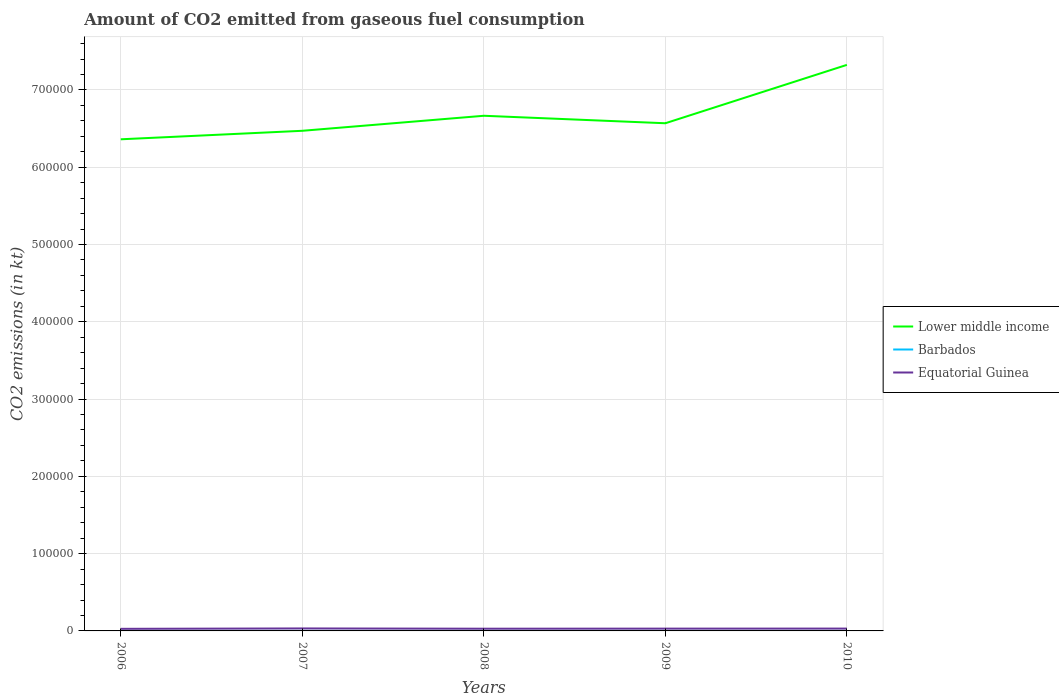How many different coloured lines are there?
Offer a very short reply. 3. Is the number of lines equal to the number of legend labels?
Offer a terse response. Yes. Across all years, what is the maximum amount of CO2 emitted in Equatorial Guinea?
Ensure brevity in your answer.  2709.91. In which year was the amount of CO2 emitted in Lower middle income maximum?
Give a very brief answer. 2006. What is the total amount of CO2 emitted in Lower middle income in the graph?
Offer a terse response. -8.53e+04. What is the difference between the highest and the second highest amount of CO2 emitted in Barbados?
Keep it short and to the point. 22. Is the amount of CO2 emitted in Lower middle income strictly greater than the amount of CO2 emitted in Equatorial Guinea over the years?
Your answer should be very brief. No. How many lines are there?
Offer a very short reply. 3. What is the difference between two consecutive major ticks on the Y-axis?
Keep it short and to the point. 1.00e+05. Are the values on the major ticks of Y-axis written in scientific E-notation?
Your answer should be very brief. No. Does the graph contain grids?
Keep it short and to the point. Yes. Where does the legend appear in the graph?
Give a very brief answer. Center right. How are the legend labels stacked?
Your answer should be compact. Vertical. What is the title of the graph?
Keep it short and to the point. Amount of CO2 emitted from gaseous fuel consumption. What is the label or title of the X-axis?
Provide a short and direct response. Years. What is the label or title of the Y-axis?
Provide a succinct answer. CO2 emissions (in kt). What is the CO2 emissions (in kt) in Lower middle income in 2006?
Offer a terse response. 6.36e+05. What is the CO2 emissions (in kt) in Barbados in 2006?
Your response must be concise. 51.34. What is the CO2 emissions (in kt) of Equatorial Guinea in 2006?
Keep it short and to the point. 2709.91. What is the CO2 emissions (in kt) of Lower middle income in 2007?
Ensure brevity in your answer.  6.47e+05. What is the CO2 emissions (in kt) in Barbados in 2007?
Offer a terse response. 44. What is the CO2 emissions (in kt) in Equatorial Guinea in 2007?
Give a very brief answer. 3212.29. What is the CO2 emissions (in kt) in Lower middle income in 2008?
Offer a terse response. 6.67e+05. What is the CO2 emissions (in kt) in Barbados in 2008?
Keep it short and to the point. 51.34. What is the CO2 emissions (in kt) of Equatorial Guinea in 2008?
Give a very brief answer. 2860.26. What is the CO2 emissions (in kt) in Lower middle income in 2009?
Make the answer very short. 6.57e+05. What is the CO2 emissions (in kt) of Barbados in 2009?
Provide a succinct answer. 33. What is the CO2 emissions (in kt) in Equatorial Guinea in 2009?
Offer a very short reply. 2973.94. What is the CO2 emissions (in kt) of Lower middle income in 2010?
Offer a terse response. 7.32e+05. What is the CO2 emissions (in kt) in Barbados in 2010?
Provide a succinct answer. 29.34. What is the CO2 emissions (in kt) of Equatorial Guinea in 2010?
Provide a succinct answer. 3032.61. Across all years, what is the maximum CO2 emissions (in kt) in Lower middle income?
Offer a terse response. 7.32e+05. Across all years, what is the maximum CO2 emissions (in kt) of Barbados?
Give a very brief answer. 51.34. Across all years, what is the maximum CO2 emissions (in kt) in Equatorial Guinea?
Offer a terse response. 3212.29. Across all years, what is the minimum CO2 emissions (in kt) in Lower middle income?
Ensure brevity in your answer.  6.36e+05. Across all years, what is the minimum CO2 emissions (in kt) of Barbados?
Provide a short and direct response. 29.34. Across all years, what is the minimum CO2 emissions (in kt) in Equatorial Guinea?
Your response must be concise. 2709.91. What is the total CO2 emissions (in kt) in Lower middle income in the graph?
Make the answer very short. 3.34e+06. What is the total CO2 emissions (in kt) of Barbados in the graph?
Make the answer very short. 209.02. What is the total CO2 emissions (in kt) in Equatorial Guinea in the graph?
Keep it short and to the point. 1.48e+04. What is the difference between the CO2 emissions (in kt) in Lower middle income in 2006 and that in 2007?
Provide a short and direct response. -1.10e+04. What is the difference between the CO2 emissions (in kt) in Barbados in 2006 and that in 2007?
Provide a succinct answer. 7.33. What is the difference between the CO2 emissions (in kt) of Equatorial Guinea in 2006 and that in 2007?
Ensure brevity in your answer.  -502.38. What is the difference between the CO2 emissions (in kt) of Lower middle income in 2006 and that in 2008?
Ensure brevity in your answer.  -3.04e+04. What is the difference between the CO2 emissions (in kt) in Barbados in 2006 and that in 2008?
Give a very brief answer. 0. What is the difference between the CO2 emissions (in kt) of Equatorial Guinea in 2006 and that in 2008?
Your response must be concise. -150.35. What is the difference between the CO2 emissions (in kt) of Lower middle income in 2006 and that in 2009?
Offer a terse response. -2.08e+04. What is the difference between the CO2 emissions (in kt) in Barbados in 2006 and that in 2009?
Give a very brief answer. 18.34. What is the difference between the CO2 emissions (in kt) of Equatorial Guinea in 2006 and that in 2009?
Your response must be concise. -264.02. What is the difference between the CO2 emissions (in kt) in Lower middle income in 2006 and that in 2010?
Your answer should be compact. -9.63e+04. What is the difference between the CO2 emissions (in kt) of Barbados in 2006 and that in 2010?
Provide a succinct answer. 22. What is the difference between the CO2 emissions (in kt) of Equatorial Guinea in 2006 and that in 2010?
Your answer should be compact. -322.7. What is the difference between the CO2 emissions (in kt) of Lower middle income in 2007 and that in 2008?
Your answer should be very brief. -1.94e+04. What is the difference between the CO2 emissions (in kt) of Barbados in 2007 and that in 2008?
Offer a very short reply. -7.33. What is the difference between the CO2 emissions (in kt) in Equatorial Guinea in 2007 and that in 2008?
Your answer should be compact. 352.03. What is the difference between the CO2 emissions (in kt) in Lower middle income in 2007 and that in 2009?
Give a very brief answer. -9769.55. What is the difference between the CO2 emissions (in kt) in Barbados in 2007 and that in 2009?
Your response must be concise. 11. What is the difference between the CO2 emissions (in kt) in Equatorial Guinea in 2007 and that in 2009?
Your answer should be compact. 238.35. What is the difference between the CO2 emissions (in kt) in Lower middle income in 2007 and that in 2010?
Offer a terse response. -8.53e+04. What is the difference between the CO2 emissions (in kt) of Barbados in 2007 and that in 2010?
Your response must be concise. 14.67. What is the difference between the CO2 emissions (in kt) in Equatorial Guinea in 2007 and that in 2010?
Your answer should be compact. 179.68. What is the difference between the CO2 emissions (in kt) of Lower middle income in 2008 and that in 2009?
Provide a short and direct response. 9672.51. What is the difference between the CO2 emissions (in kt) of Barbados in 2008 and that in 2009?
Offer a terse response. 18.34. What is the difference between the CO2 emissions (in kt) of Equatorial Guinea in 2008 and that in 2009?
Your answer should be compact. -113.68. What is the difference between the CO2 emissions (in kt) in Lower middle income in 2008 and that in 2010?
Make the answer very short. -6.59e+04. What is the difference between the CO2 emissions (in kt) of Barbados in 2008 and that in 2010?
Your answer should be compact. 22. What is the difference between the CO2 emissions (in kt) of Equatorial Guinea in 2008 and that in 2010?
Your answer should be very brief. -172.35. What is the difference between the CO2 emissions (in kt) in Lower middle income in 2009 and that in 2010?
Offer a very short reply. -7.55e+04. What is the difference between the CO2 emissions (in kt) of Barbados in 2009 and that in 2010?
Ensure brevity in your answer.  3.67. What is the difference between the CO2 emissions (in kt) in Equatorial Guinea in 2009 and that in 2010?
Offer a terse response. -58.67. What is the difference between the CO2 emissions (in kt) of Lower middle income in 2006 and the CO2 emissions (in kt) of Barbados in 2007?
Your answer should be very brief. 6.36e+05. What is the difference between the CO2 emissions (in kt) of Lower middle income in 2006 and the CO2 emissions (in kt) of Equatorial Guinea in 2007?
Offer a terse response. 6.33e+05. What is the difference between the CO2 emissions (in kt) in Barbados in 2006 and the CO2 emissions (in kt) in Equatorial Guinea in 2007?
Provide a succinct answer. -3160.95. What is the difference between the CO2 emissions (in kt) in Lower middle income in 2006 and the CO2 emissions (in kt) in Barbados in 2008?
Provide a short and direct response. 6.36e+05. What is the difference between the CO2 emissions (in kt) of Lower middle income in 2006 and the CO2 emissions (in kt) of Equatorial Guinea in 2008?
Your answer should be compact. 6.33e+05. What is the difference between the CO2 emissions (in kt) of Barbados in 2006 and the CO2 emissions (in kt) of Equatorial Guinea in 2008?
Offer a very short reply. -2808.92. What is the difference between the CO2 emissions (in kt) of Lower middle income in 2006 and the CO2 emissions (in kt) of Barbados in 2009?
Your response must be concise. 6.36e+05. What is the difference between the CO2 emissions (in kt) in Lower middle income in 2006 and the CO2 emissions (in kt) in Equatorial Guinea in 2009?
Give a very brief answer. 6.33e+05. What is the difference between the CO2 emissions (in kt) of Barbados in 2006 and the CO2 emissions (in kt) of Equatorial Guinea in 2009?
Make the answer very short. -2922.6. What is the difference between the CO2 emissions (in kt) in Lower middle income in 2006 and the CO2 emissions (in kt) in Barbados in 2010?
Your response must be concise. 6.36e+05. What is the difference between the CO2 emissions (in kt) of Lower middle income in 2006 and the CO2 emissions (in kt) of Equatorial Guinea in 2010?
Offer a terse response. 6.33e+05. What is the difference between the CO2 emissions (in kt) in Barbados in 2006 and the CO2 emissions (in kt) in Equatorial Guinea in 2010?
Your answer should be compact. -2981.27. What is the difference between the CO2 emissions (in kt) in Lower middle income in 2007 and the CO2 emissions (in kt) in Barbados in 2008?
Offer a very short reply. 6.47e+05. What is the difference between the CO2 emissions (in kt) of Lower middle income in 2007 and the CO2 emissions (in kt) of Equatorial Guinea in 2008?
Ensure brevity in your answer.  6.44e+05. What is the difference between the CO2 emissions (in kt) in Barbados in 2007 and the CO2 emissions (in kt) in Equatorial Guinea in 2008?
Offer a very short reply. -2816.26. What is the difference between the CO2 emissions (in kt) in Lower middle income in 2007 and the CO2 emissions (in kt) in Barbados in 2009?
Give a very brief answer. 6.47e+05. What is the difference between the CO2 emissions (in kt) in Lower middle income in 2007 and the CO2 emissions (in kt) in Equatorial Guinea in 2009?
Your answer should be very brief. 6.44e+05. What is the difference between the CO2 emissions (in kt) of Barbados in 2007 and the CO2 emissions (in kt) of Equatorial Guinea in 2009?
Provide a succinct answer. -2929.93. What is the difference between the CO2 emissions (in kt) in Lower middle income in 2007 and the CO2 emissions (in kt) in Barbados in 2010?
Provide a succinct answer. 6.47e+05. What is the difference between the CO2 emissions (in kt) of Lower middle income in 2007 and the CO2 emissions (in kt) of Equatorial Guinea in 2010?
Your answer should be compact. 6.44e+05. What is the difference between the CO2 emissions (in kt) of Barbados in 2007 and the CO2 emissions (in kt) of Equatorial Guinea in 2010?
Your answer should be very brief. -2988.61. What is the difference between the CO2 emissions (in kt) in Lower middle income in 2008 and the CO2 emissions (in kt) in Barbados in 2009?
Your answer should be compact. 6.67e+05. What is the difference between the CO2 emissions (in kt) in Lower middle income in 2008 and the CO2 emissions (in kt) in Equatorial Guinea in 2009?
Offer a terse response. 6.64e+05. What is the difference between the CO2 emissions (in kt) in Barbados in 2008 and the CO2 emissions (in kt) in Equatorial Guinea in 2009?
Offer a very short reply. -2922.6. What is the difference between the CO2 emissions (in kt) of Lower middle income in 2008 and the CO2 emissions (in kt) of Barbados in 2010?
Make the answer very short. 6.67e+05. What is the difference between the CO2 emissions (in kt) of Lower middle income in 2008 and the CO2 emissions (in kt) of Equatorial Guinea in 2010?
Keep it short and to the point. 6.64e+05. What is the difference between the CO2 emissions (in kt) of Barbados in 2008 and the CO2 emissions (in kt) of Equatorial Guinea in 2010?
Make the answer very short. -2981.27. What is the difference between the CO2 emissions (in kt) of Lower middle income in 2009 and the CO2 emissions (in kt) of Barbados in 2010?
Your response must be concise. 6.57e+05. What is the difference between the CO2 emissions (in kt) in Lower middle income in 2009 and the CO2 emissions (in kt) in Equatorial Guinea in 2010?
Provide a succinct answer. 6.54e+05. What is the difference between the CO2 emissions (in kt) of Barbados in 2009 and the CO2 emissions (in kt) of Equatorial Guinea in 2010?
Ensure brevity in your answer.  -2999.61. What is the average CO2 emissions (in kt) of Lower middle income per year?
Offer a terse response. 6.68e+05. What is the average CO2 emissions (in kt) in Barbados per year?
Provide a short and direct response. 41.8. What is the average CO2 emissions (in kt) in Equatorial Guinea per year?
Give a very brief answer. 2957.8. In the year 2006, what is the difference between the CO2 emissions (in kt) in Lower middle income and CO2 emissions (in kt) in Barbados?
Offer a terse response. 6.36e+05. In the year 2006, what is the difference between the CO2 emissions (in kt) in Lower middle income and CO2 emissions (in kt) in Equatorial Guinea?
Offer a very short reply. 6.33e+05. In the year 2006, what is the difference between the CO2 emissions (in kt) of Barbados and CO2 emissions (in kt) of Equatorial Guinea?
Make the answer very short. -2658.57. In the year 2007, what is the difference between the CO2 emissions (in kt) of Lower middle income and CO2 emissions (in kt) of Barbados?
Your response must be concise. 6.47e+05. In the year 2007, what is the difference between the CO2 emissions (in kt) of Lower middle income and CO2 emissions (in kt) of Equatorial Guinea?
Your answer should be compact. 6.44e+05. In the year 2007, what is the difference between the CO2 emissions (in kt) of Barbados and CO2 emissions (in kt) of Equatorial Guinea?
Your response must be concise. -3168.29. In the year 2008, what is the difference between the CO2 emissions (in kt) in Lower middle income and CO2 emissions (in kt) in Barbados?
Keep it short and to the point. 6.67e+05. In the year 2008, what is the difference between the CO2 emissions (in kt) in Lower middle income and CO2 emissions (in kt) in Equatorial Guinea?
Give a very brief answer. 6.64e+05. In the year 2008, what is the difference between the CO2 emissions (in kt) in Barbados and CO2 emissions (in kt) in Equatorial Guinea?
Provide a short and direct response. -2808.92. In the year 2009, what is the difference between the CO2 emissions (in kt) in Lower middle income and CO2 emissions (in kt) in Barbados?
Provide a succinct answer. 6.57e+05. In the year 2009, what is the difference between the CO2 emissions (in kt) in Lower middle income and CO2 emissions (in kt) in Equatorial Guinea?
Provide a short and direct response. 6.54e+05. In the year 2009, what is the difference between the CO2 emissions (in kt) of Barbados and CO2 emissions (in kt) of Equatorial Guinea?
Provide a short and direct response. -2940.93. In the year 2010, what is the difference between the CO2 emissions (in kt) in Lower middle income and CO2 emissions (in kt) in Barbados?
Your response must be concise. 7.32e+05. In the year 2010, what is the difference between the CO2 emissions (in kt) of Lower middle income and CO2 emissions (in kt) of Equatorial Guinea?
Ensure brevity in your answer.  7.29e+05. In the year 2010, what is the difference between the CO2 emissions (in kt) of Barbados and CO2 emissions (in kt) of Equatorial Guinea?
Make the answer very short. -3003.27. What is the ratio of the CO2 emissions (in kt) of Equatorial Guinea in 2006 to that in 2007?
Your response must be concise. 0.84. What is the ratio of the CO2 emissions (in kt) of Lower middle income in 2006 to that in 2008?
Keep it short and to the point. 0.95. What is the ratio of the CO2 emissions (in kt) in Lower middle income in 2006 to that in 2009?
Your answer should be very brief. 0.97. What is the ratio of the CO2 emissions (in kt) of Barbados in 2006 to that in 2009?
Offer a terse response. 1.56. What is the ratio of the CO2 emissions (in kt) of Equatorial Guinea in 2006 to that in 2009?
Give a very brief answer. 0.91. What is the ratio of the CO2 emissions (in kt) in Lower middle income in 2006 to that in 2010?
Offer a terse response. 0.87. What is the ratio of the CO2 emissions (in kt) of Barbados in 2006 to that in 2010?
Your answer should be compact. 1.75. What is the ratio of the CO2 emissions (in kt) in Equatorial Guinea in 2006 to that in 2010?
Offer a terse response. 0.89. What is the ratio of the CO2 emissions (in kt) of Lower middle income in 2007 to that in 2008?
Provide a short and direct response. 0.97. What is the ratio of the CO2 emissions (in kt) in Equatorial Guinea in 2007 to that in 2008?
Provide a succinct answer. 1.12. What is the ratio of the CO2 emissions (in kt) of Lower middle income in 2007 to that in 2009?
Provide a short and direct response. 0.99. What is the ratio of the CO2 emissions (in kt) in Barbados in 2007 to that in 2009?
Offer a terse response. 1.33. What is the ratio of the CO2 emissions (in kt) in Equatorial Guinea in 2007 to that in 2009?
Give a very brief answer. 1.08. What is the ratio of the CO2 emissions (in kt) in Lower middle income in 2007 to that in 2010?
Provide a short and direct response. 0.88. What is the ratio of the CO2 emissions (in kt) of Equatorial Guinea in 2007 to that in 2010?
Make the answer very short. 1.06. What is the ratio of the CO2 emissions (in kt) of Lower middle income in 2008 to that in 2009?
Keep it short and to the point. 1.01. What is the ratio of the CO2 emissions (in kt) in Barbados in 2008 to that in 2009?
Provide a short and direct response. 1.56. What is the ratio of the CO2 emissions (in kt) in Equatorial Guinea in 2008 to that in 2009?
Keep it short and to the point. 0.96. What is the ratio of the CO2 emissions (in kt) of Lower middle income in 2008 to that in 2010?
Your response must be concise. 0.91. What is the ratio of the CO2 emissions (in kt) of Equatorial Guinea in 2008 to that in 2010?
Make the answer very short. 0.94. What is the ratio of the CO2 emissions (in kt) of Lower middle income in 2009 to that in 2010?
Provide a succinct answer. 0.9. What is the ratio of the CO2 emissions (in kt) in Barbados in 2009 to that in 2010?
Give a very brief answer. 1.12. What is the ratio of the CO2 emissions (in kt) in Equatorial Guinea in 2009 to that in 2010?
Your response must be concise. 0.98. What is the difference between the highest and the second highest CO2 emissions (in kt) of Lower middle income?
Your response must be concise. 6.59e+04. What is the difference between the highest and the second highest CO2 emissions (in kt) in Barbados?
Provide a short and direct response. 0. What is the difference between the highest and the second highest CO2 emissions (in kt) of Equatorial Guinea?
Ensure brevity in your answer.  179.68. What is the difference between the highest and the lowest CO2 emissions (in kt) of Lower middle income?
Offer a terse response. 9.63e+04. What is the difference between the highest and the lowest CO2 emissions (in kt) of Barbados?
Your answer should be compact. 22. What is the difference between the highest and the lowest CO2 emissions (in kt) of Equatorial Guinea?
Keep it short and to the point. 502.38. 